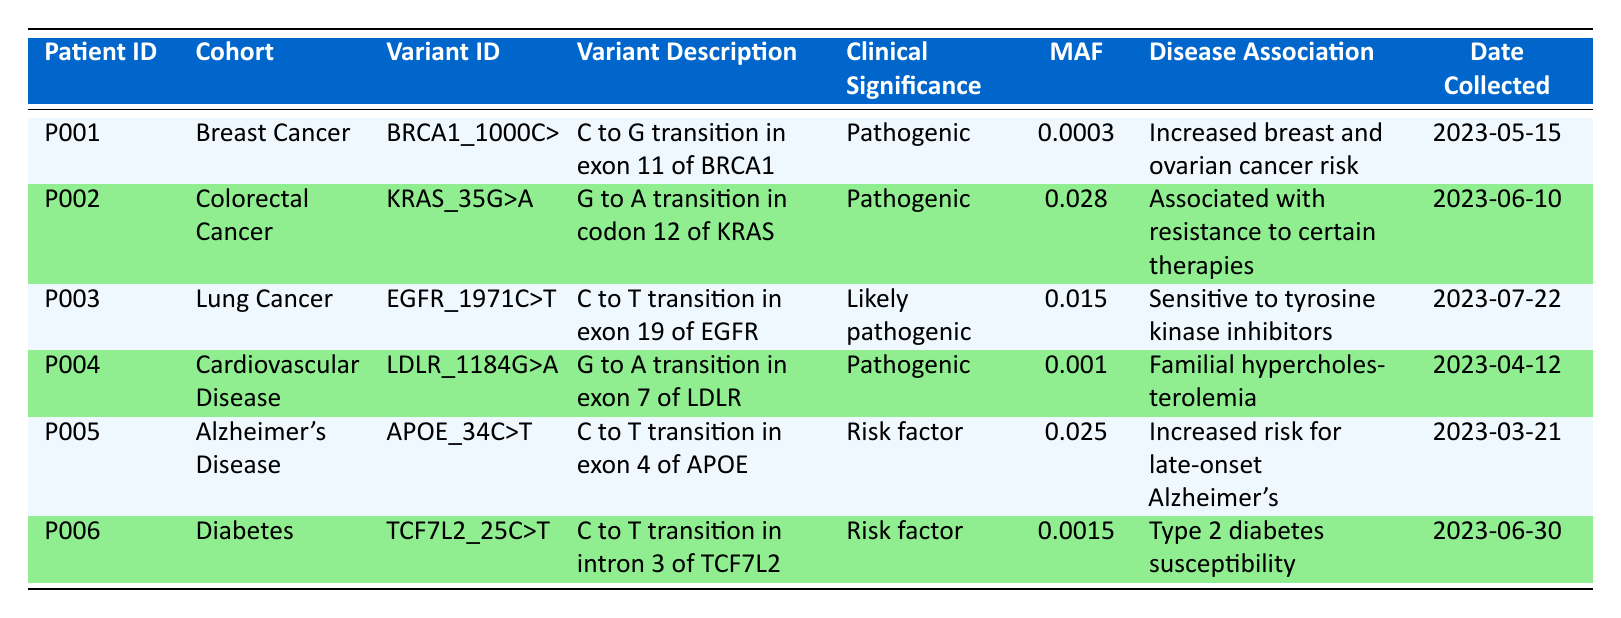What is the clinical significance of the variant identified in patient P001? The variant identified in patient P001 is "BRCA1_1000C>G" and is listed in the clinical significance column as "Pathogenic."
Answer: Pathogenic How many patients are associated with a variant that has a minor allele frequency of greater than 0.02? From the table, two variants, "KRAS_35G>A" with an MAF of 0.028 and "APOE_34C>T" with an MAF of 0.025, are greater than 0.02. Therefore, there are two patients associated.
Answer: 2 Is the variant "TCF7L2_25C>T" associated with an increased risk for late-onset Alzheimer’s? "TCF7L2_25C>T" is associated with type 2 diabetes susceptibility according to the table, and there is no mention of Alzheimer's disease.
Answer: No What is the date collected for the variant in patient P006? The table indicates that the date collected for patient P006 is "2023-06-30."
Answer: 2023-06-30 Which cohort has the highest minor allele frequency (MAF) of variants identified? The cohort "Colorectal Cancer" has the highest MAF documented at 0.028 from the variant "KRAS_35G>A."
Answer: Colorectal Cancer How many variants are classified as "Risk factor"? The table lists two variants classified as "Risk factor," which are "APOE_34C>T" and "TCF7L2_25C>T."
Answer: 2 Is there a variant in the cohort for Alzheimer's Disease that is classified as "Pathogenic"? The only variant listed for Alzheimer's Disease is "APOE_34C>T," which is classified as a "Risk factor," not "Pathogenic."
Answer: No What is the difference in minor allele frequency between the variant in patient P002 and patient P005? Patient P002 has a MAF of 0.028, and patient P005 has a MAF of 0.025. The difference is calculated as 0.028 - 0.025 = 0.003.
Answer: 0.003 